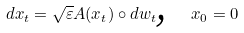Convert formula to latex. <formula><loc_0><loc_0><loc_500><loc_500>d x _ { t } = \sqrt { \varepsilon } A ( x _ { t } ) \circ d w _ { t } \text {, \ \ } x _ { 0 } = 0</formula> 